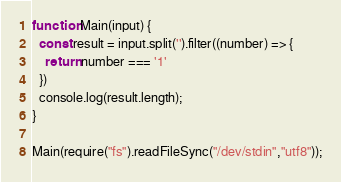Convert code to text. <code><loc_0><loc_0><loc_500><loc_500><_JavaScript_>function Main(input) {
  const result = input.split('').filter((number) => {
    return number === '1'
  })
  console.log(result.length);
}

Main(require("fs").readFileSync("/dev/stdin","utf8"));
</code> 